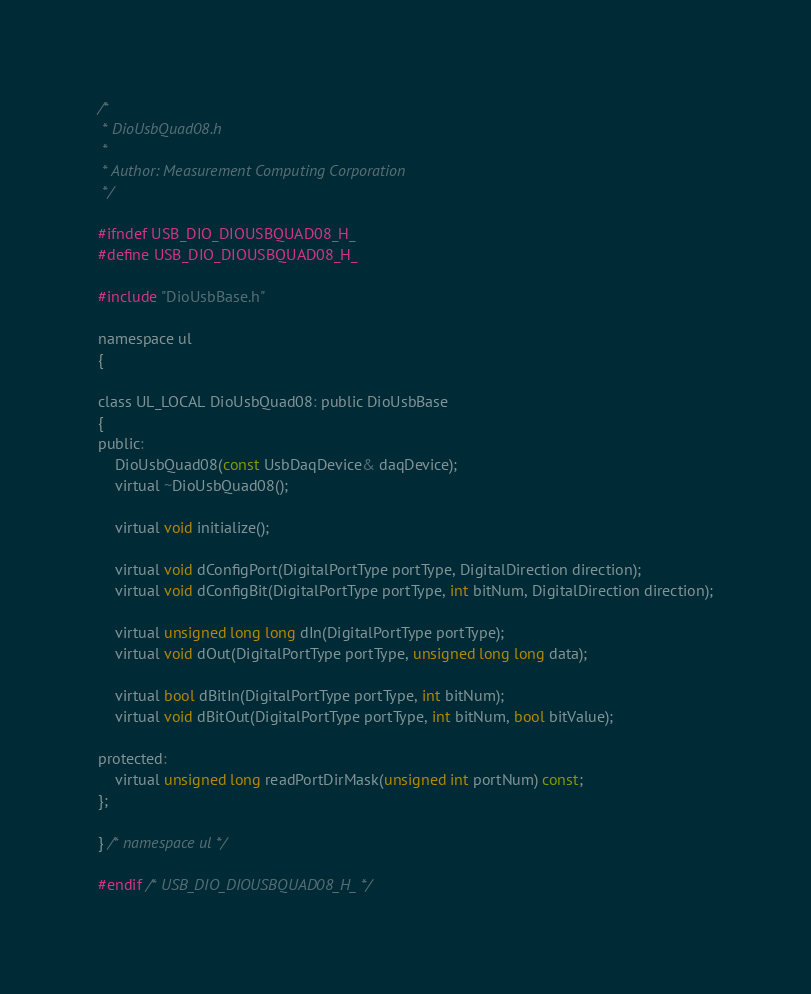<code> <loc_0><loc_0><loc_500><loc_500><_C_>/*
 * DioUsbQuad08.h
 *
 * Author: Measurement Computing Corporation
 */

#ifndef USB_DIO_DIOUSBQUAD08_H_
#define USB_DIO_DIOUSBQUAD08_H_

#include "DioUsbBase.h"

namespace ul
{

class UL_LOCAL DioUsbQuad08: public DioUsbBase
{
public:
	DioUsbQuad08(const UsbDaqDevice& daqDevice);
	virtual ~DioUsbQuad08();

	virtual void initialize();

	virtual void dConfigPort(DigitalPortType portType, DigitalDirection direction);
	virtual void dConfigBit(DigitalPortType portType, int bitNum, DigitalDirection direction);

	virtual unsigned long long dIn(DigitalPortType portType);
	virtual void dOut(DigitalPortType portType, unsigned long long data);

	virtual bool dBitIn(DigitalPortType portType, int bitNum);
	virtual void dBitOut(DigitalPortType portType, int bitNum, bool bitValue);

protected:
	virtual unsigned long readPortDirMask(unsigned int portNum) const;
};

} /* namespace ul */

#endif /* USB_DIO_DIOUSBQUAD08_H_ */
</code> 